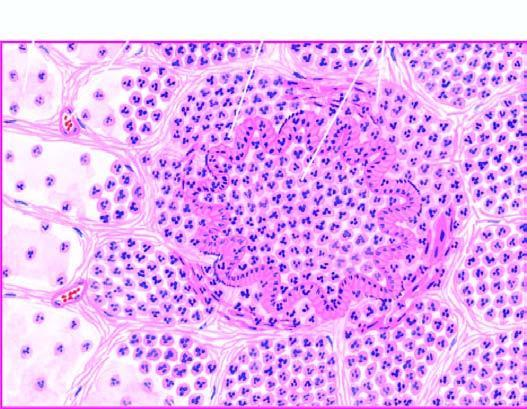what are the bronchioles as well as the adjacent alveoli filled with?
Answer the question using a single word or phrase. Exudate consisting chiefly of neutrophils 